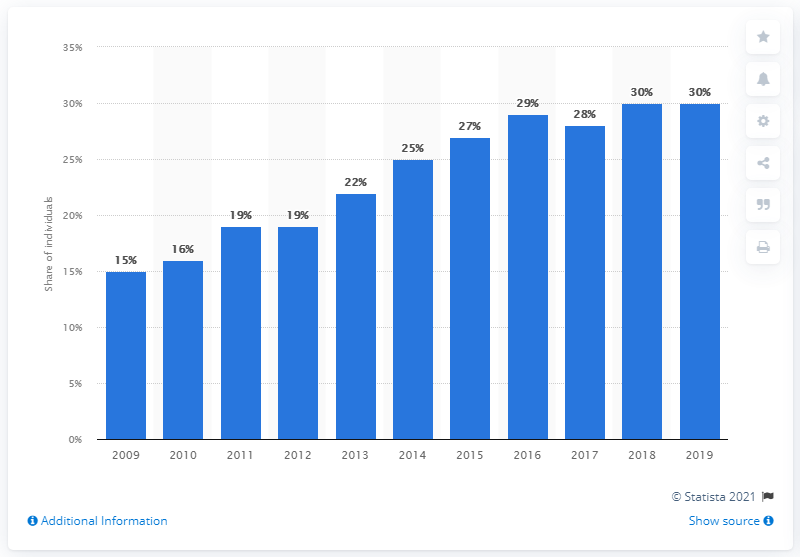Draw attention to some important aspects in this diagram. In the UK, the last time people purchased groceries online was in 2009. 